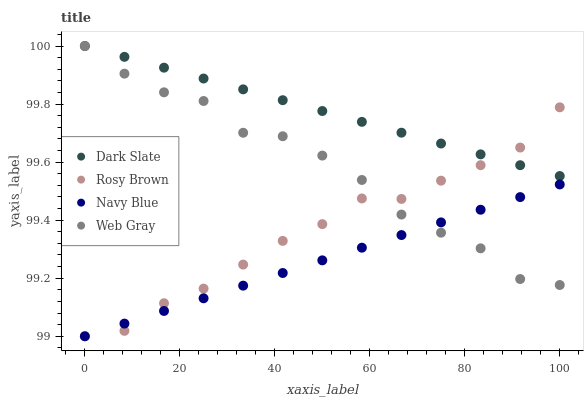Does Navy Blue have the minimum area under the curve?
Answer yes or no. Yes. Does Dark Slate have the maximum area under the curve?
Answer yes or no. Yes. Does Rosy Brown have the minimum area under the curve?
Answer yes or no. No. Does Rosy Brown have the maximum area under the curve?
Answer yes or no. No. Is Dark Slate the smoothest?
Answer yes or no. Yes. Is Web Gray the roughest?
Answer yes or no. Yes. Is Rosy Brown the smoothest?
Answer yes or no. No. Is Rosy Brown the roughest?
Answer yes or no. No. Does Rosy Brown have the lowest value?
Answer yes or no. Yes. Does Web Gray have the lowest value?
Answer yes or no. No. Does Web Gray have the highest value?
Answer yes or no. Yes. Does Rosy Brown have the highest value?
Answer yes or no. No. Is Navy Blue less than Dark Slate?
Answer yes or no. Yes. Is Dark Slate greater than Navy Blue?
Answer yes or no. Yes. Does Navy Blue intersect Rosy Brown?
Answer yes or no. Yes. Is Navy Blue less than Rosy Brown?
Answer yes or no. No. Is Navy Blue greater than Rosy Brown?
Answer yes or no. No. Does Navy Blue intersect Dark Slate?
Answer yes or no. No. 